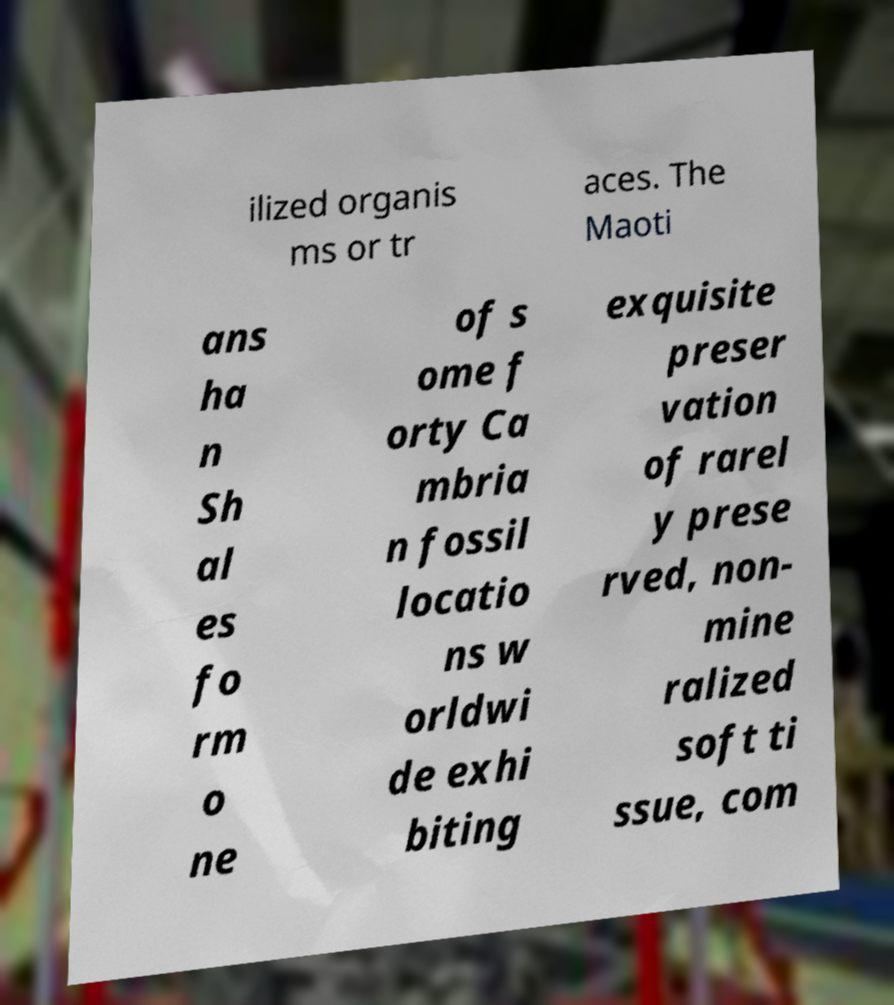Please read and relay the text visible in this image. What does it say? ilized organis ms or tr aces. The Maoti ans ha n Sh al es fo rm o ne of s ome f orty Ca mbria n fossil locatio ns w orldwi de exhi biting exquisite preser vation of rarel y prese rved, non- mine ralized soft ti ssue, com 